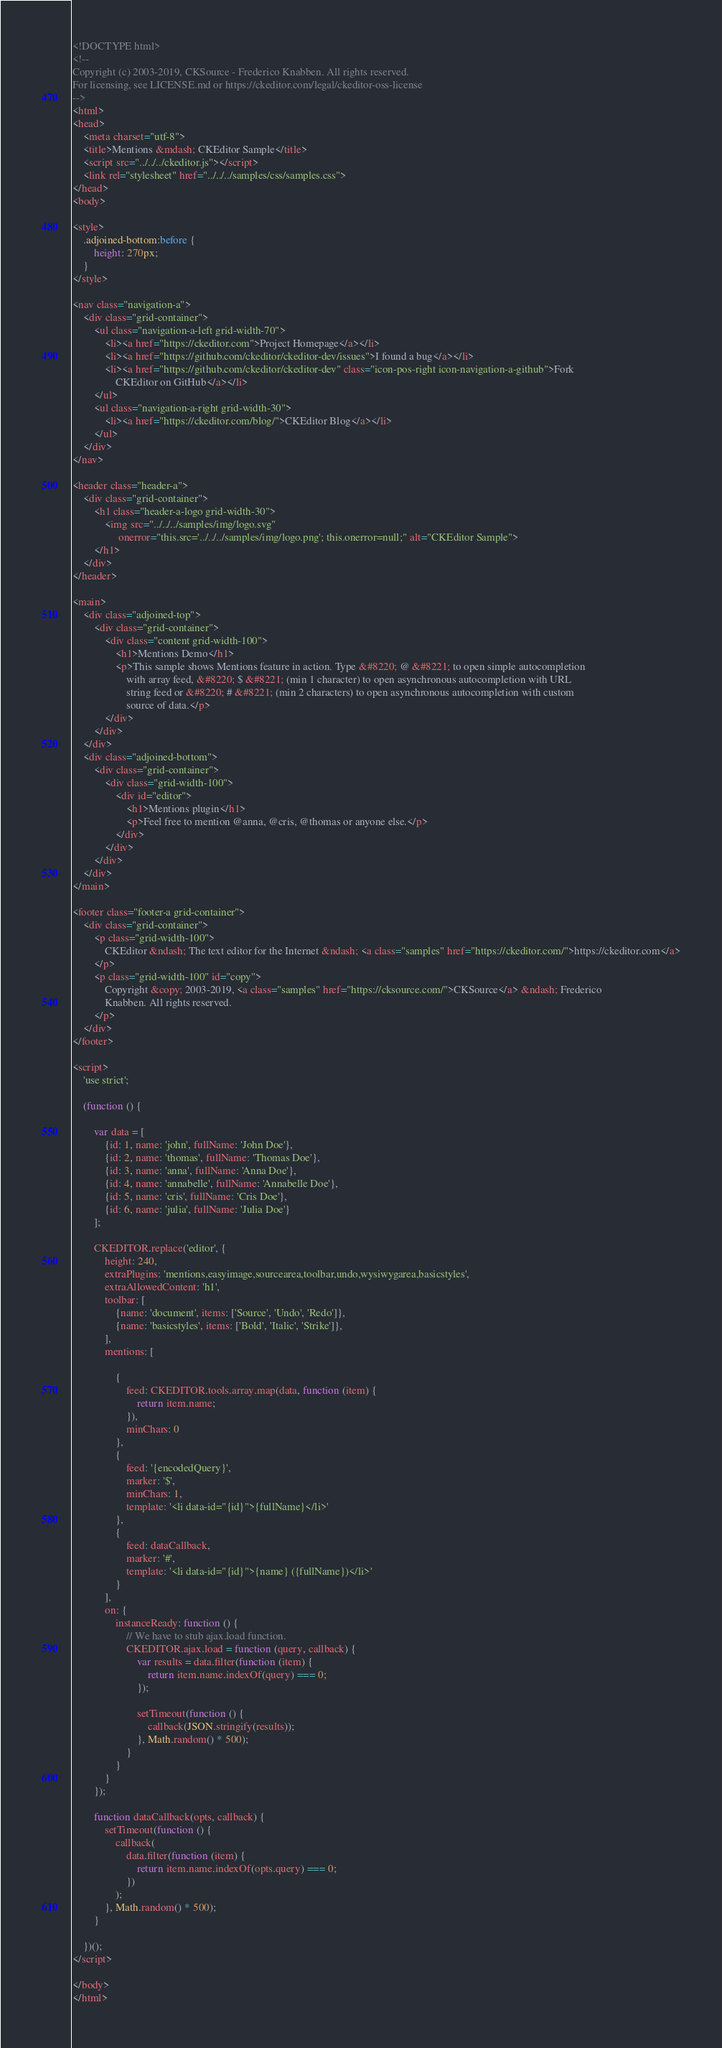Convert code to text. <code><loc_0><loc_0><loc_500><loc_500><_HTML_><!DOCTYPE html>
<!--
Copyright (c) 2003-2019, CKSource - Frederico Knabben. All rights reserved.
For licensing, see LICENSE.md or https://ckeditor.com/legal/ckeditor-oss-license
-->
<html>
<head>
    <meta charset="utf-8">
    <title>Mentions &mdash; CKEditor Sample</title>
    <script src="../../../ckeditor.js"></script>
    <link rel="stylesheet" href="../../../samples/css/samples.css">
</head>
<body>

<style>
    .adjoined-bottom:before {
        height: 270px;
    }
</style>

<nav class="navigation-a">
    <div class="grid-container">
        <ul class="navigation-a-left grid-width-70">
            <li><a href="https://ckeditor.com">Project Homepage</a></li>
            <li><a href="https://github.com/ckeditor/ckeditor-dev/issues">I found a bug</a></li>
            <li><a href="https://github.com/ckeditor/ckeditor-dev" class="icon-pos-right icon-navigation-a-github">Fork
                CKEditor on GitHub</a></li>
        </ul>
        <ul class="navigation-a-right grid-width-30">
            <li><a href="https://ckeditor.com/blog/">CKEditor Blog</a></li>
        </ul>
    </div>
</nav>

<header class="header-a">
    <div class="grid-container">
        <h1 class="header-a-logo grid-width-30">
            <img src="../../../samples/img/logo.svg"
                 onerror="this.src='../../../samples/img/logo.png'; this.onerror=null;" alt="CKEditor Sample">
        </h1>
    </div>
</header>

<main>
    <div class="adjoined-top">
        <div class="grid-container">
            <div class="content grid-width-100">
                <h1>Mentions Demo</h1>
                <p>This sample shows Mentions feature in action. Type &#8220; @ &#8221; to open simple autocompletion
                    with array feed, &#8220; $ &#8221; (min 1 character) to open asynchronous autocompletion with URL
                    string feed or &#8220; # &#8221; (min 2 characters) to open asynchronous autocompletion with custom
                    source of data.</p>
            </div>
        </div>
    </div>
    <div class="adjoined-bottom">
        <div class="grid-container">
            <div class="grid-width-100">
                <div id="editor">
                    <h1>Mentions plugin</h1>
                    <p>Feel free to mention @anna, @cris, @thomas or anyone else.</p>
                </div>
            </div>
        </div>
    </div>
</main>

<footer class="footer-a grid-container">
    <div class="grid-container">
        <p class="grid-width-100">
            CKEditor &ndash; The text editor for the Internet &ndash; <a class="samples" href="https://ckeditor.com/">https://ckeditor.com</a>
        </p>
        <p class="grid-width-100" id="copy">
            Copyright &copy; 2003-2019, <a class="samples" href="https://cksource.com/">CKSource</a> &ndash; Frederico
            Knabben. All rights reserved.
        </p>
    </div>
</footer>

<script>
    'use strict';

    (function () {

        var data = [
            {id: 1, name: 'john', fullName: 'John Doe'},
            {id: 2, name: 'thomas', fullName: 'Thomas Doe'},
            {id: 3, name: 'anna', fullName: 'Anna Doe'},
            {id: 4, name: 'annabelle', fullName: 'Annabelle Doe'},
            {id: 5, name: 'cris', fullName: 'Cris Doe'},
            {id: 6, name: 'julia', fullName: 'Julia Doe'}
        ];

        CKEDITOR.replace('editor', {
            height: 240,
            extraPlugins: 'mentions,easyimage,sourcearea,toolbar,undo,wysiwygarea,basicstyles',
            extraAllowedContent: 'h1',
            toolbar: [
                {name: 'document', items: ['Source', 'Undo', 'Redo']},
                {name: 'basicstyles', items: ['Bold', 'Italic', 'Strike']},
            ],
            mentions: [

                {
                    feed: CKEDITOR.tools.array.map(data, function (item) {
                        return item.name;
                    }),
                    minChars: 0
                },
                {
                    feed: '{encodedQuery}',
                    marker: '$',
                    minChars: 1,
                    template: '<li data-id="{id}">{fullName}</li>'
                },
                {
                    feed: dataCallback,
                    marker: '#',
                    template: '<li data-id="{id}">{name} ({fullName})</li>'
                }
            ],
            on: {
                instanceReady: function () {
                    // We have to stub ajax.load function.
                    CKEDITOR.ajax.load = function (query, callback) {
                        var results = data.filter(function (item) {
                            return item.name.indexOf(query) === 0;
                        });

                        setTimeout(function () {
                            callback(JSON.stringify(results));
                        }, Math.random() * 500);
                    }
                }
            }
        });

        function dataCallback(opts, callback) {
            setTimeout(function () {
                callback(
                    data.filter(function (item) {
                        return item.name.indexOf(opts.query) === 0;
                    })
                );
            }, Math.random() * 500);
        }

    })();
</script>

</body>
</html>
</code> 